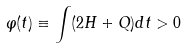Convert formula to latex. <formula><loc_0><loc_0><loc_500><loc_500>\varphi ( t ) \equiv \int ( 2 H + Q ) d t > 0</formula> 